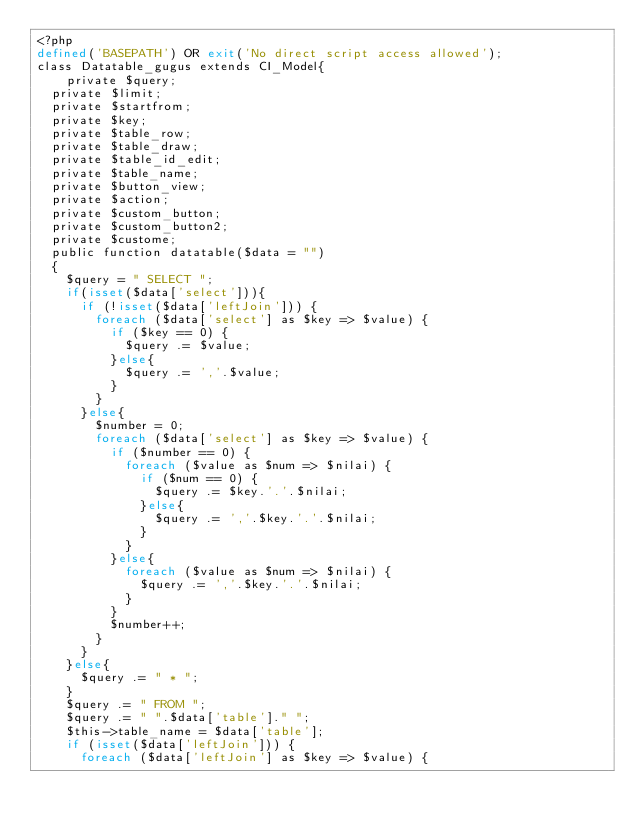Convert code to text. <code><loc_0><loc_0><loc_500><loc_500><_PHP_><?php
defined('BASEPATH') OR exit('No direct script access allowed');
class Datatable_gugus extends CI_Model{
    private $query;
	private $limit;
	private $startfrom;
	private $key;
	private $table_row;
	private $table_draw;
	private $table_id_edit;
	private $table_name;
	private $button_view;
	private $action;
	private $custom_button;
	private $custom_button2;
	private $custome;
	public function datatable($data = "")
	{
		$query = " SELECT ";
		if(isset($data['select'])){
			if (!isset($data['leftJoin'])) {
				foreach ($data['select'] as $key => $value) {
					if ($key == 0) {
						$query .= $value;
					}else{
						$query .= ','.$value;
					}
				}
			}else{
				$number = 0;
				foreach ($data['select'] as $key => $value) {
					if ($number == 0) {
						foreach ($value as $num => $nilai) {
							if ($num == 0) {
								$query .= $key.'.'.$nilai;
							}else{
								$query .= ','.$key.'.'.$nilai;
							}
						}
					}else{
						foreach ($value as $num => $nilai) {
							$query .= ','.$key.'.'.$nilai;
						}
					}
					$number++;
				}
			}
		}else{
			$query .= " * ";
		}
		$query .= " FROM ";
		$query .= " ".$data['table']." ";
		$this->table_name = $data['table'];
		if (isset($data['leftJoin'])) {
			foreach ($data['leftJoin'] as $key => $value) {</code> 